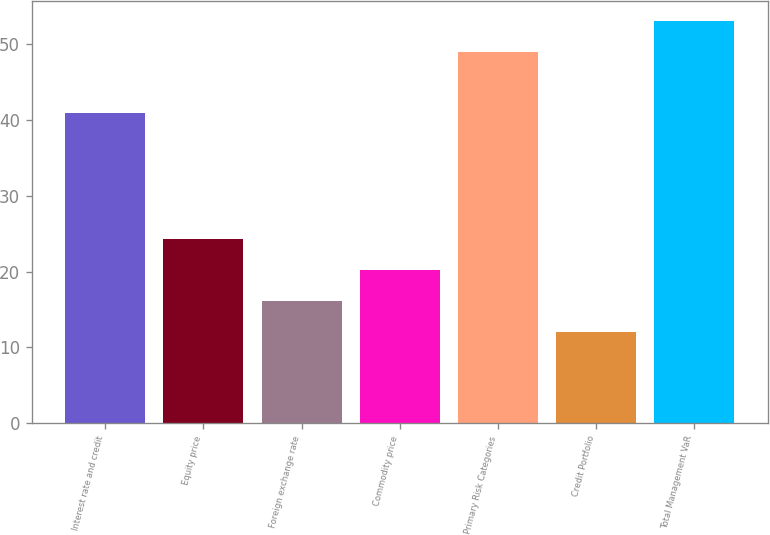Convert chart to OTSL. <chart><loc_0><loc_0><loc_500><loc_500><bar_chart><fcel>Interest rate and credit<fcel>Equity price<fcel>Foreign exchange rate<fcel>Commodity price<fcel>Primary Risk Categories<fcel>Credit Portfolio<fcel>Total Management VaR<nl><fcel>41<fcel>24.3<fcel>16.1<fcel>20.2<fcel>49<fcel>12<fcel>53.1<nl></chart> 